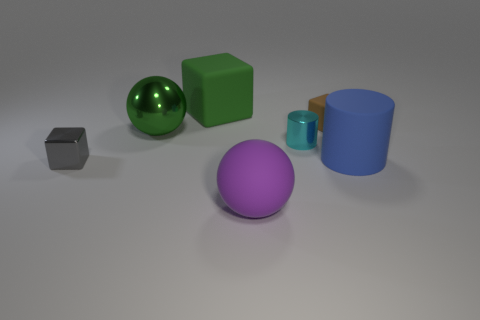What size is the shiny thing behind the cyan thing?
Provide a succinct answer. Large. Is the big metal thing the same shape as the large purple thing?
Provide a succinct answer. Yes. What number of small objects are green cubes or cylinders?
Make the answer very short. 1. There is a small brown rubber block; are there any small cyan things behind it?
Ensure brevity in your answer.  No. Are there the same number of big matte cylinders that are to the left of the green block and green things?
Ensure brevity in your answer.  No. There is a metal object that is the same shape as the large purple matte object; what is its size?
Provide a short and direct response. Large. Is the shape of the big green matte thing the same as the small thing that is to the left of the big green sphere?
Keep it short and to the point. Yes. What is the size of the cube on the right side of the large thing in front of the large cylinder?
Make the answer very short. Small. Is the number of tiny cyan metallic objects that are in front of the blue cylinder the same as the number of large metallic things that are in front of the small gray object?
Your response must be concise. Yes. What is the color of the other matte thing that is the same shape as the tiny brown matte object?
Offer a very short reply. Green. 